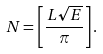<formula> <loc_0><loc_0><loc_500><loc_500>N = \left [ \frac { L \sqrt { E } } { \pi } \right ] .</formula> 